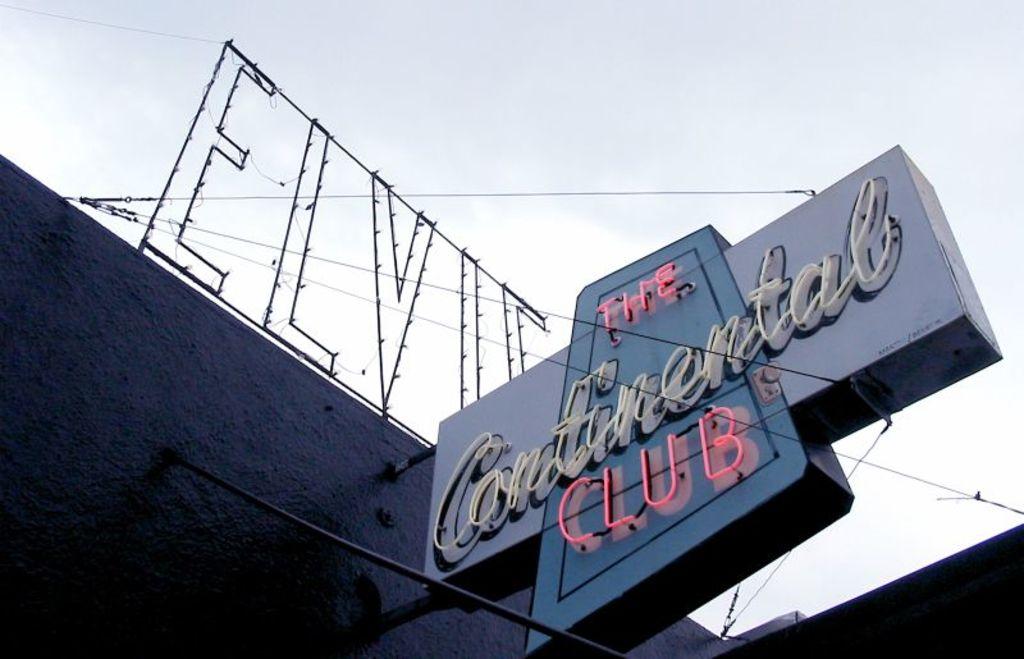What club is this?
Make the answer very short. The continental club. 